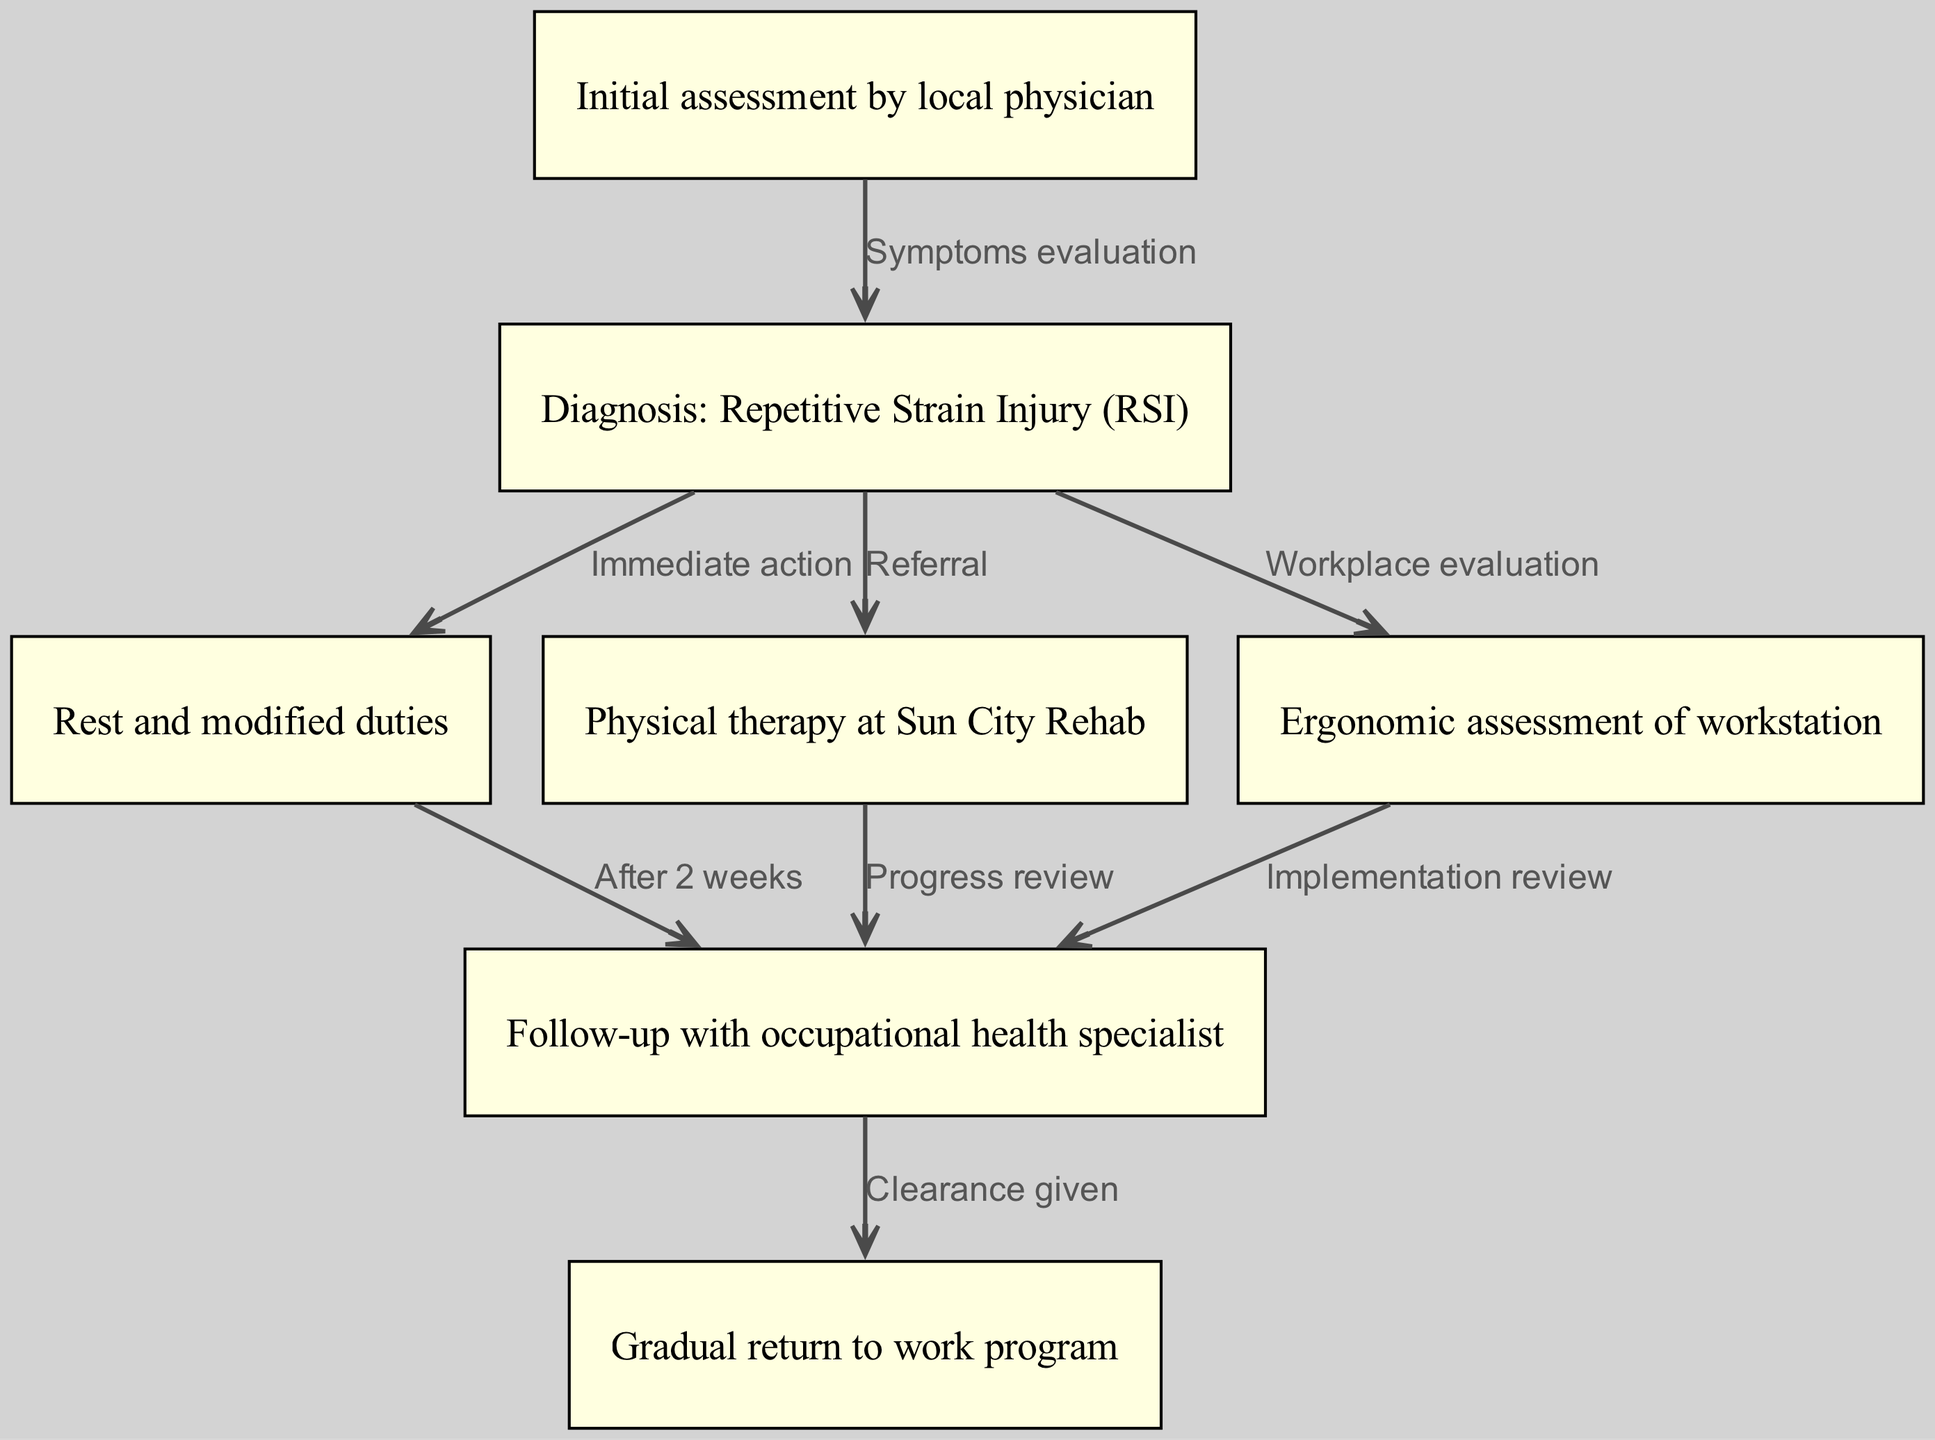What's the first step in the pathway? The first node in the diagram is "Initial assessment by local physician," which is where the process begins.
Answer: Initial assessment by local physician How many nodes are in the diagram? Counting all nodes listed, there are a total of 7 nodes: initial assessment, diagnosis, rest, physical therapy, ergonomic assessment, follow-up, and return to work.
Answer: 7 What is the relationship between diagnosis and rest? The edge connecting "Diagnosis: Repetitive Strain Injury (RSI)" to "Rest and modified duties" indicates an immediate action based on the diagnosis, suggesting that the employee should start resting right away.
Answer: Immediate action Which node follows physical therapy? Following the "Physical therapy at Sun City Rehab," the next step is a "Follow-up with occupational health specialist," as indicated by the arrow from physical therapy to follow up.
Answer: Follow-up with occupational health specialist What happens after "Follow-up"? After the "Follow-up," the pathway indicates a "Gradual return to work program" occurs upon receiving clearance from the specialist.
Answer: Gradual return to work program What does the ergonomic assessment lead to? The "Ergonomic assessment of workstation" leads to a "Follow-up with occupational health specialist," suggesting that recommendations for workstation modifications are reviewed.
Answer: Follow-up with occupational health specialist Why is rest necessary in this pathway? Rest is deemed necessary as an immediate action after diagnosing a repetitive strain injury, indicating the need for recovery to prevent further injury.
Answer: Immediate action How long after rest is the follow-up? The follow-up occurs "After 2 weeks" post the rest phase, indicating a specified timeline for evaluating progress.
Answer: After 2 weeks 